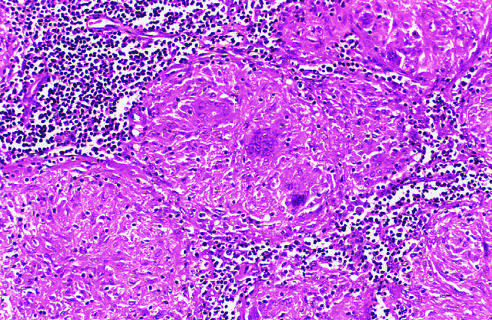what does the granuloma in the center show?
Answer the question using a single word or phrase. Multinucleate giant cells 